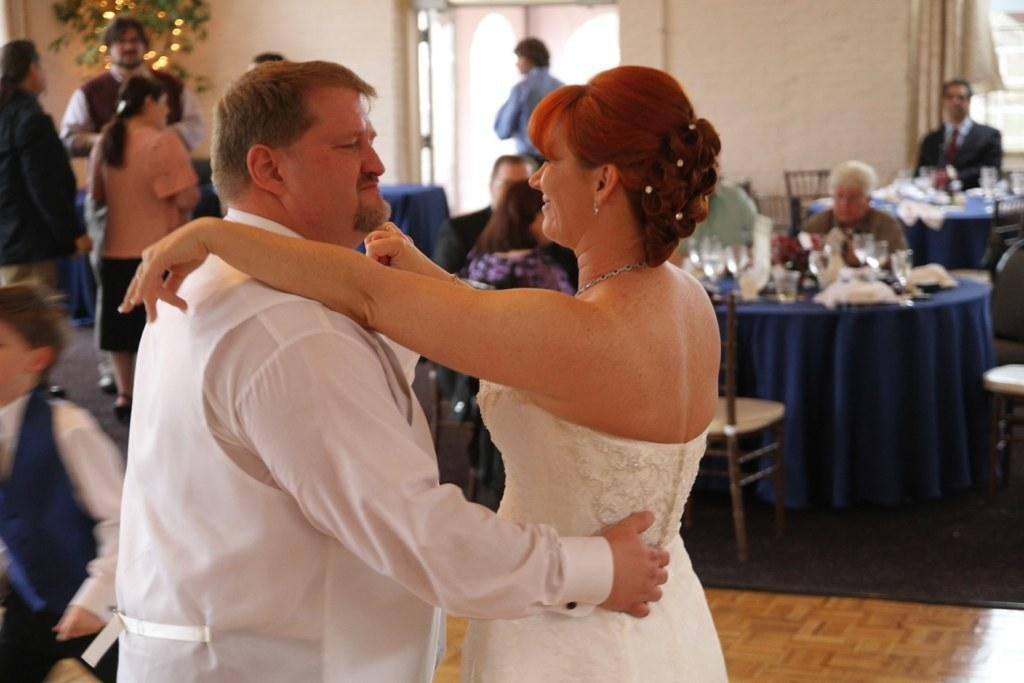What are the persons wearing in the image? The persons are wearing white dresses in the image. What are the persons doing while wearing the white dresses? The persons are holding each other in the image. Are there any other people in the image besides the persons in white dresses? Yes, there is a group of people beside them in the image. What type of angle is being used to take the picture of the persons in white dresses? The provided facts do not mention any specific angle used to take the picture, so it cannot be determined from the image. 